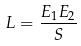<formula> <loc_0><loc_0><loc_500><loc_500>L = \frac { E _ { 1 } E _ { 2 } } { S }</formula> 